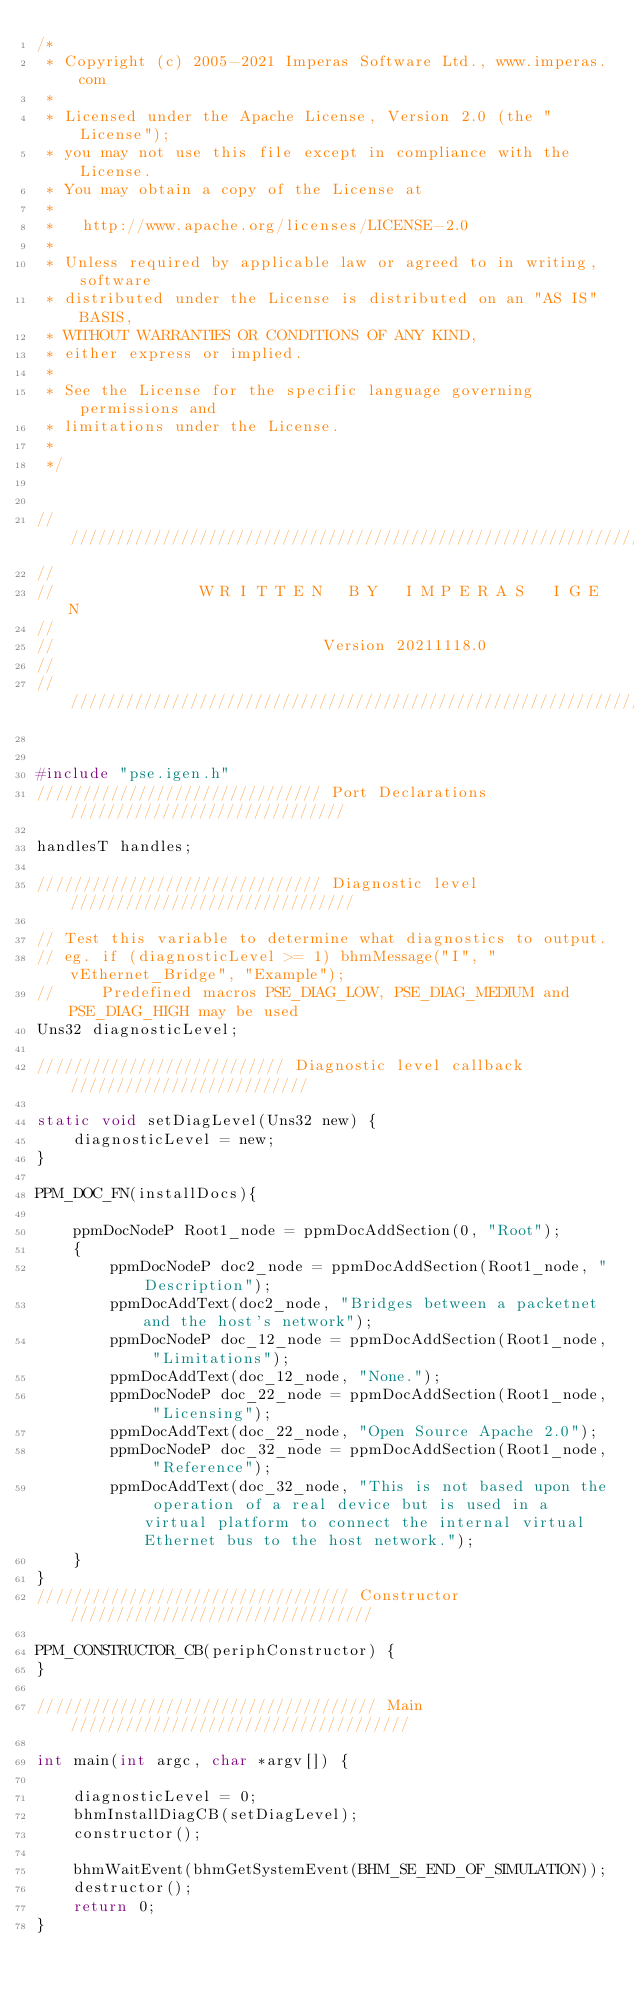Convert code to text. <code><loc_0><loc_0><loc_500><loc_500><_C_>/*
 * Copyright (c) 2005-2021 Imperas Software Ltd., www.imperas.com
 *
 * Licensed under the Apache License, Version 2.0 (the "License");
 * you may not use this file except in compliance with the License.
 * You may obtain a copy of the License at
 *
 *   http://www.apache.org/licenses/LICENSE-2.0
 *
 * Unless required by applicable law or agreed to in writing, software
 * distributed under the License is distributed on an "AS IS" BASIS,
 * WITHOUT WARRANTIES OR CONDITIONS OF ANY KIND,
 * either express or implied.
 *
 * See the License for the specific language governing permissions and
 * limitations under the License.
 *
 */


////////////////////////////////////////////////////////////////////////////////
//
//                W R I T T E N   B Y   I M P E R A S   I G E N
//
//                             Version 20211118.0
//
////////////////////////////////////////////////////////////////////////////////


#include "pse.igen.h"
/////////////////////////////// Port Declarations //////////////////////////////

handlesT handles;

/////////////////////////////// Diagnostic level ///////////////////////////////

// Test this variable to determine what diagnostics to output.
// eg. if (diagnosticLevel >= 1) bhmMessage("I", "vEthernet_Bridge", "Example");
//     Predefined macros PSE_DIAG_LOW, PSE_DIAG_MEDIUM and PSE_DIAG_HIGH may be used
Uns32 diagnosticLevel;

/////////////////////////// Diagnostic level callback //////////////////////////

static void setDiagLevel(Uns32 new) {
    diagnosticLevel = new;
}

PPM_DOC_FN(installDocs){

    ppmDocNodeP Root1_node = ppmDocAddSection(0, "Root");
    {
        ppmDocNodeP doc2_node = ppmDocAddSection(Root1_node, "Description");
        ppmDocAddText(doc2_node, "Bridges between a packetnet and the host's network");
        ppmDocNodeP doc_12_node = ppmDocAddSection(Root1_node, "Limitations");
        ppmDocAddText(doc_12_node, "None.");
        ppmDocNodeP doc_22_node = ppmDocAddSection(Root1_node, "Licensing");
        ppmDocAddText(doc_22_node, "Open Source Apache 2.0");
        ppmDocNodeP doc_32_node = ppmDocAddSection(Root1_node, "Reference");
        ppmDocAddText(doc_32_node, "This is not based upon the operation of a real device but is used in a virtual platform to connect the internal virtual Ethernet bus to the host network.");
    }
}
////////////////////////////////// Constructor /////////////////////////////////

PPM_CONSTRUCTOR_CB(periphConstructor) {
}

///////////////////////////////////// Main /////////////////////////////////////

int main(int argc, char *argv[]) {

    diagnosticLevel = 0;
    bhmInstallDiagCB(setDiagLevel);
    constructor();

    bhmWaitEvent(bhmGetSystemEvent(BHM_SE_END_OF_SIMULATION));
    destructor();
    return 0;
}

</code> 